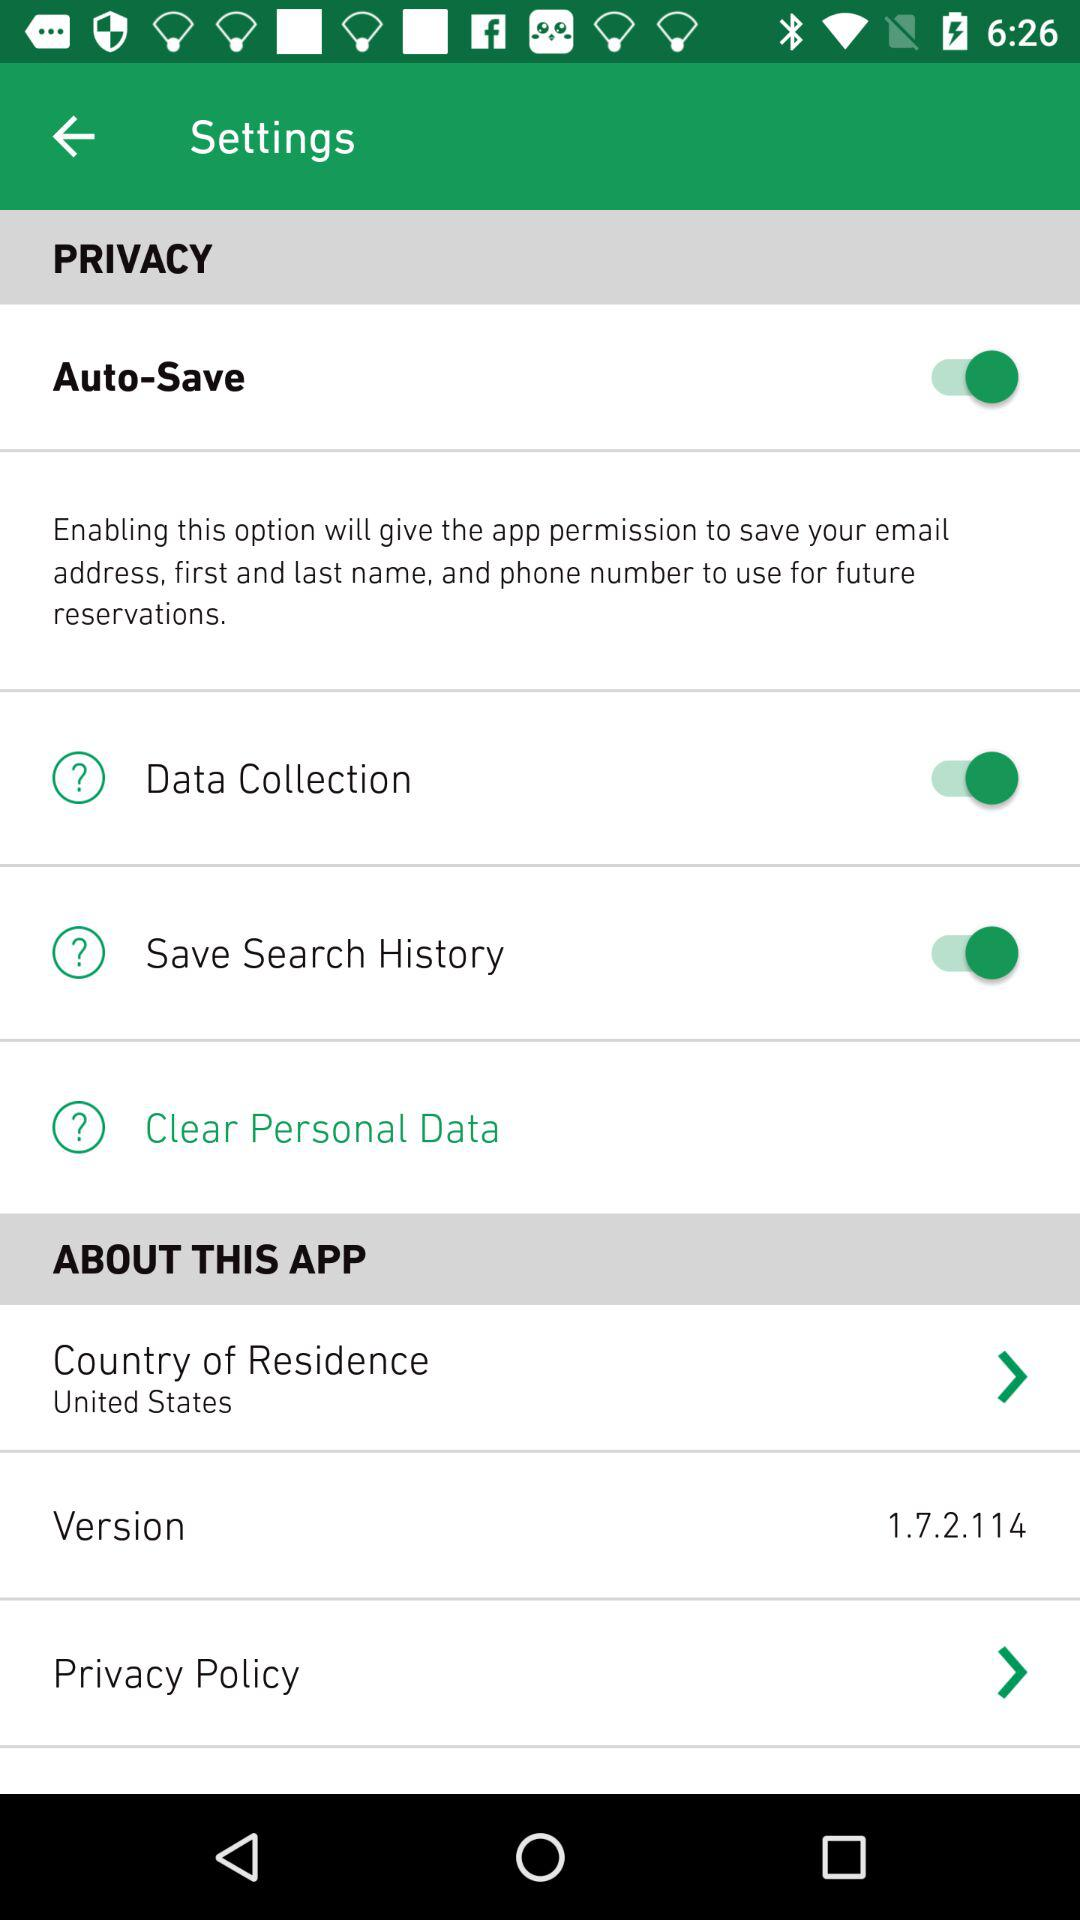What is the country of residence shown in the app? The country of residence is the United States. 